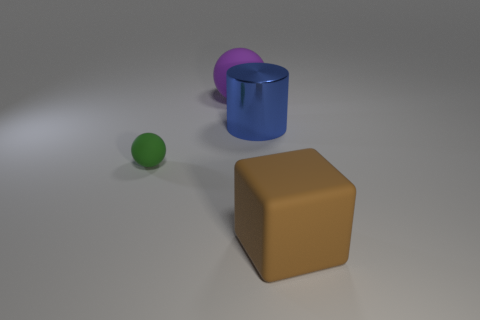There is a matte object that is both to the right of the tiny green sphere and behind the brown thing; how big is it?
Give a very brief answer. Large. What is the material of the large thing that is the same shape as the small matte thing?
Provide a short and direct response. Rubber. There is a rubber object that is right of the blue object; is its size the same as the small green rubber sphere?
Ensure brevity in your answer.  No. The rubber object that is both in front of the big blue cylinder and on the left side of the big blue thing is what color?
Make the answer very short. Green. There is a sphere that is right of the small matte sphere; what number of balls are behind it?
Offer a very short reply. 0. Do the metal thing and the large brown matte object have the same shape?
Your answer should be compact. No. Is there anything else that has the same color as the big metallic thing?
Your answer should be compact. No. There is a large blue object; is it the same shape as the large matte thing left of the big brown rubber object?
Provide a succinct answer. No. The large rubber object in front of the large rubber thing left of the big object that is in front of the big blue metal thing is what color?
Offer a terse response. Brown. Is there anything else that is made of the same material as the purple sphere?
Provide a succinct answer. Yes. 